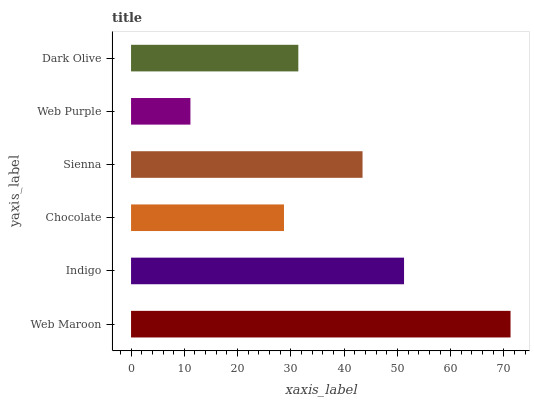Is Web Purple the minimum?
Answer yes or no. Yes. Is Web Maroon the maximum?
Answer yes or no. Yes. Is Indigo the minimum?
Answer yes or no. No. Is Indigo the maximum?
Answer yes or no. No. Is Web Maroon greater than Indigo?
Answer yes or no. Yes. Is Indigo less than Web Maroon?
Answer yes or no. Yes. Is Indigo greater than Web Maroon?
Answer yes or no. No. Is Web Maroon less than Indigo?
Answer yes or no. No. Is Sienna the high median?
Answer yes or no. Yes. Is Dark Olive the low median?
Answer yes or no. Yes. Is Dark Olive the high median?
Answer yes or no. No. Is Chocolate the low median?
Answer yes or no. No. 